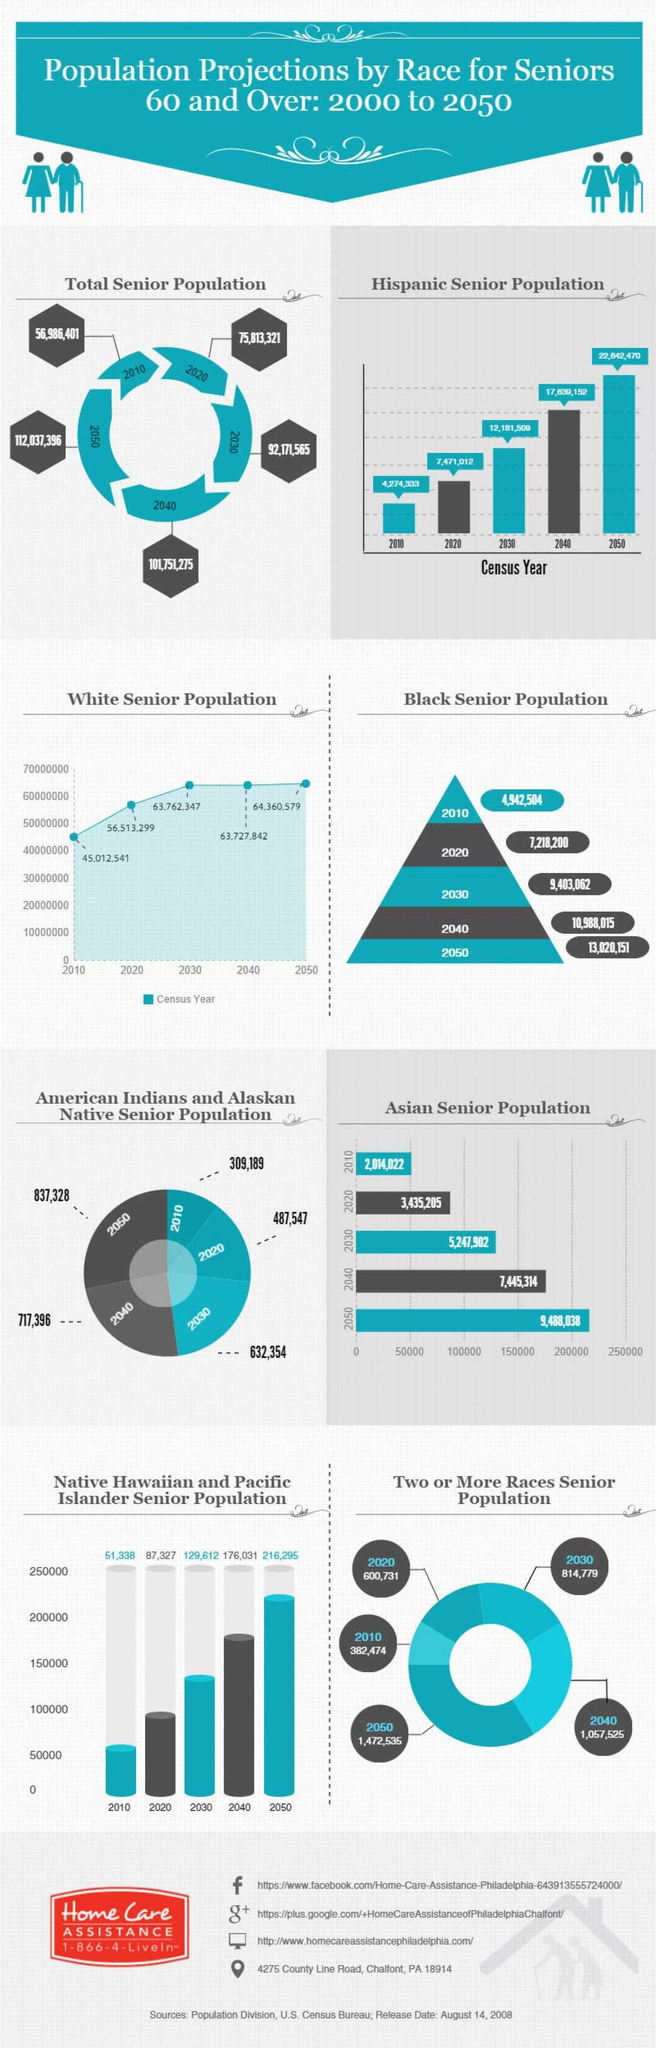Outline some significant characteristics in this image. The total senior population in 2050 is projected to be 10,286,121, which is different from the total senior population in 2040, which was 9,185,516. In 2020, the white senior population was estimated to be 11,500,758, representing a change of 758,125 from 2010. According to projections, the Asian senior population in 2040 is expected to be significantly higher than in 2030, increasing by 2,197,412 individuals. The Black senior population in the year 2040 is expected to be significantly higher than in 2030, with an increase of approximately 1.58 million individuals. In 2020, the Hispanic senior population was estimated to be 3,196,679, representing a increase of approximately 1,026,625 individuals from the Hispanic senior population in 2010. 